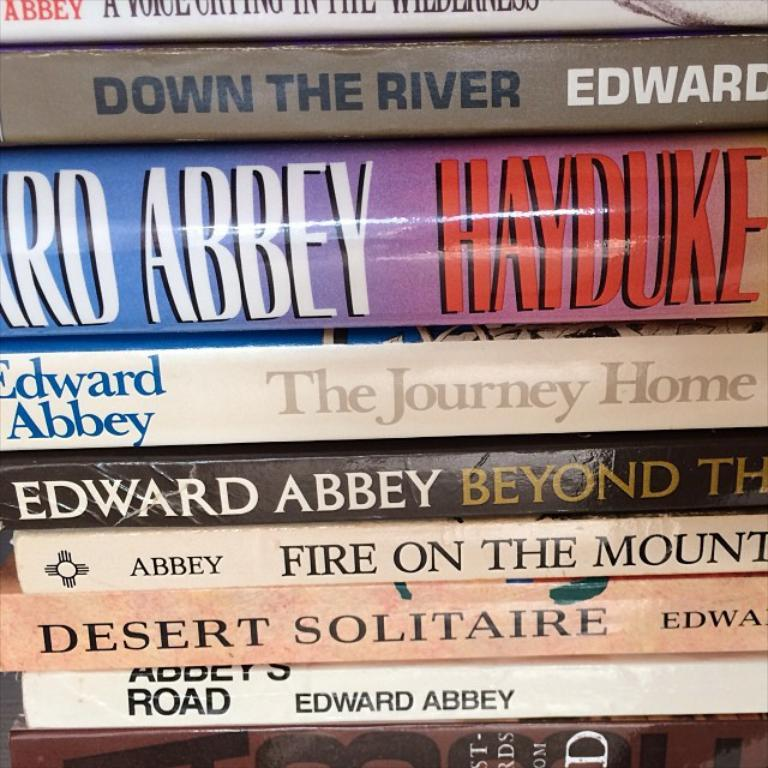What type of objects can be seen in the image? There are books in the image. Can you describe the books in the image? The books appear to be stacked or arranged in some manner. What might the presence of books in the image suggest? The presence of books might suggest that the image is related to reading, learning, or a library setting. What type of meat is being served by the governor in the image? There is no governor or meat present in the image; it only features books. 